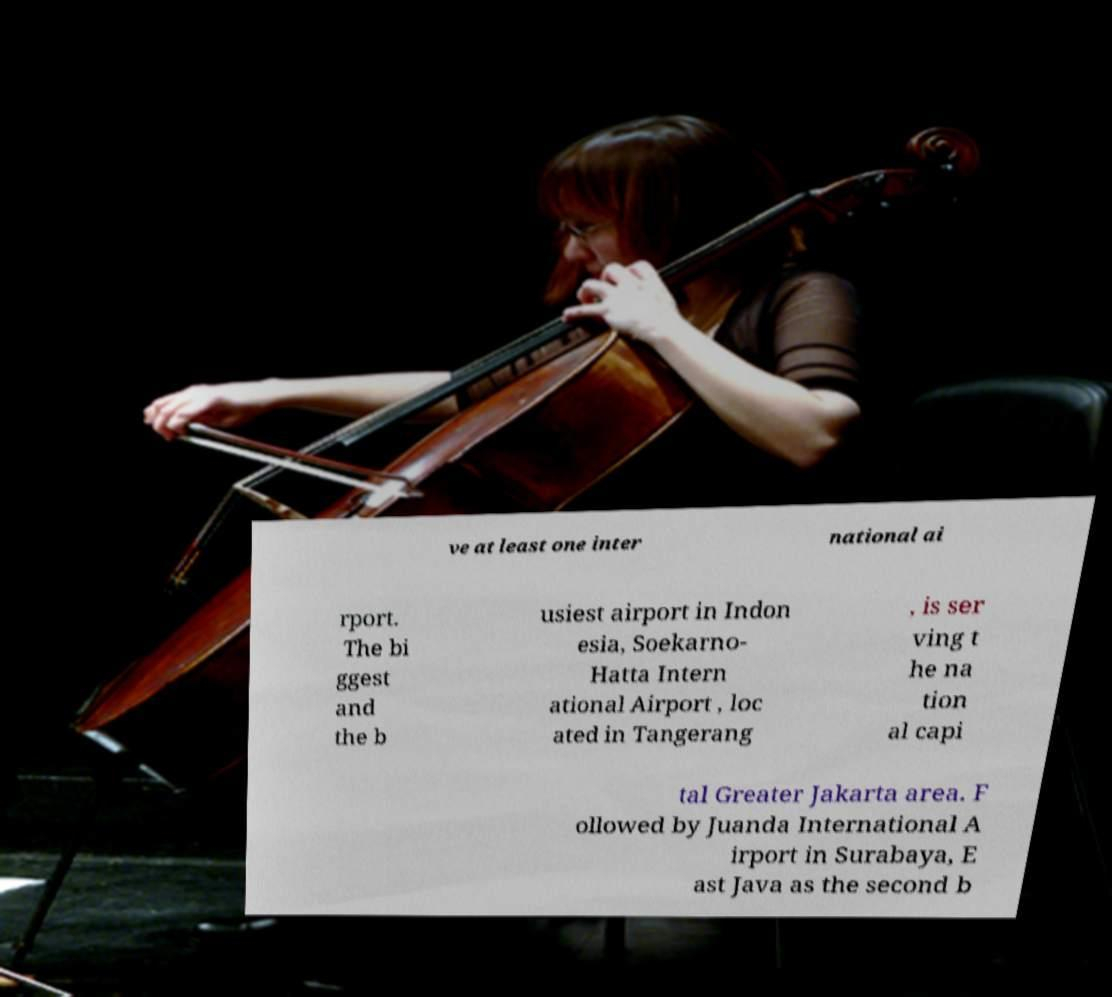There's text embedded in this image that I need extracted. Can you transcribe it verbatim? ve at least one inter national ai rport. The bi ggest and the b usiest airport in Indon esia, Soekarno- Hatta Intern ational Airport , loc ated in Tangerang , is ser ving t he na tion al capi tal Greater Jakarta area. F ollowed by Juanda International A irport in Surabaya, E ast Java as the second b 